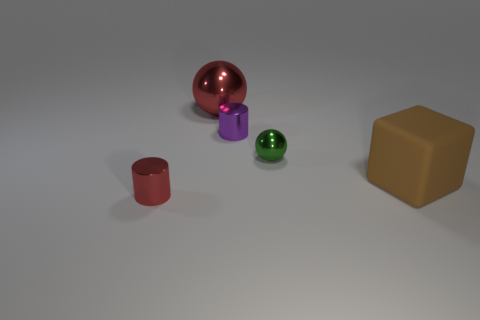Add 2 shiny things. How many objects exist? 7 Subtract all cylinders. How many objects are left? 3 Subtract all big red objects. Subtract all large metallic balls. How many objects are left? 3 Add 3 tiny metal cylinders. How many tiny metal cylinders are left? 5 Add 2 things. How many things exist? 7 Subtract 0 purple cubes. How many objects are left? 5 Subtract all brown spheres. Subtract all yellow cylinders. How many spheres are left? 2 